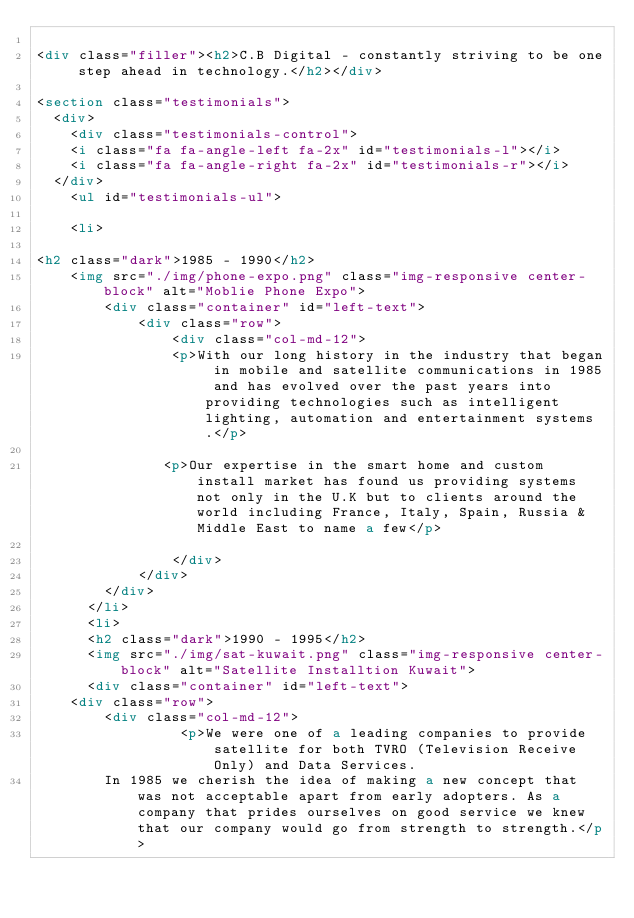Convert code to text. <code><loc_0><loc_0><loc_500><loc_500><_HTML_>
<div class="filler"><h2>C.B Digital - constantly striving to be one step ahead in technology.</h2></div>

<section class="testimonials">
  <div>
	<div class="testimonials-control">
    <i class="fa fa-angle-left fa-2x" id="testimonials-l"></i>
    <i class="fa fa-angle-right fa-2x" id="testimonials-r"></i>
  </div>
    <ul id="testimonials-ul">

    <li> 
   
<h2 class="dark">1985 - 1990</h2>
	<img src="./img/phone-expo.png" class="img-responsive center-block" alt="Moblie Phone Expo">
		<div class="container" id="left-text">
			<div class="row">
				<div class="col-md-12">	
		        <p>With our long history in the industry that began in mobile and satellite communications in 1985 and has evolved over the past years into providing technologies such as intelligent lighting, automation and entertainment systems.</p>
		        
			   <p>Our expertise in the smart home and custom install market has found us providing systems not only in the U.K but to clients around the world including France, Italy, Spain, Russia & Middle East to name a few</p>
			   
				</div>
			</div>
		</div>
      </li>
      <li>
      <h2 class="dark">1990 - 1995</h2>
      <img src="./img/sat-kuwait.png" class="img-responsive center-block" alt="Satellite Installtion Kuwait">
	  <div class="container" id="left-text">
	<div class="row">
		<div class="col-md-12">
		         <p>We were one of a leading companies to provide satellite for both TVRO (Television Receive Only) and Data Services. 
		In 1985 we cherish the idea of making a new concept that was not acceptable apart from early adopters. As a company that prides ourselves on good service we knew that our company would go from strength to strength.</p>
		</code> 